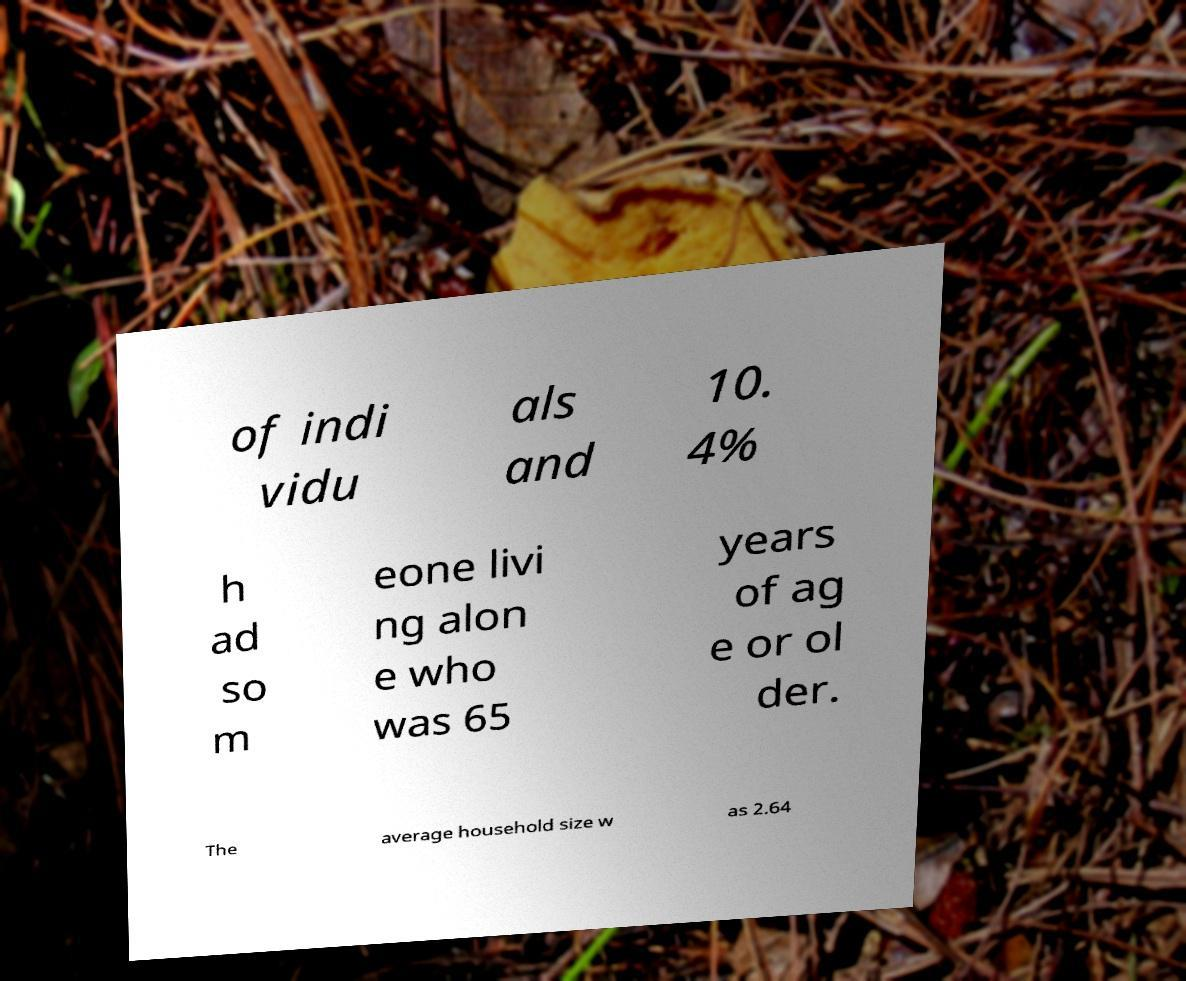Please identify and transcribe the text found in this image. of indi vidu als and 10. 4% h ad so m eone livi ng alon e who was 65 years of ag e or ol der. The average household size w as 2.64 